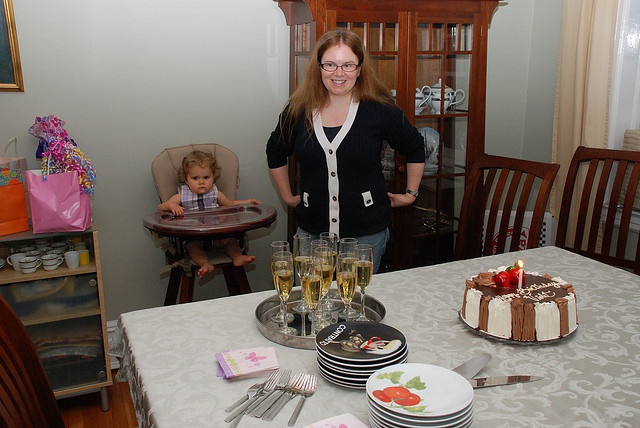Describe the objects in this image and their specific colors. I can see dining table in purple, darkgray, lightgray, and gray tones, people in purple, black, maroon, brown, and darkgray tones, chair in purple, black, maroon, and gray tones, cake in purple, maroon, tan, and darkgray tones, and chair in purple, black, gray, and maroon tones in this image. 